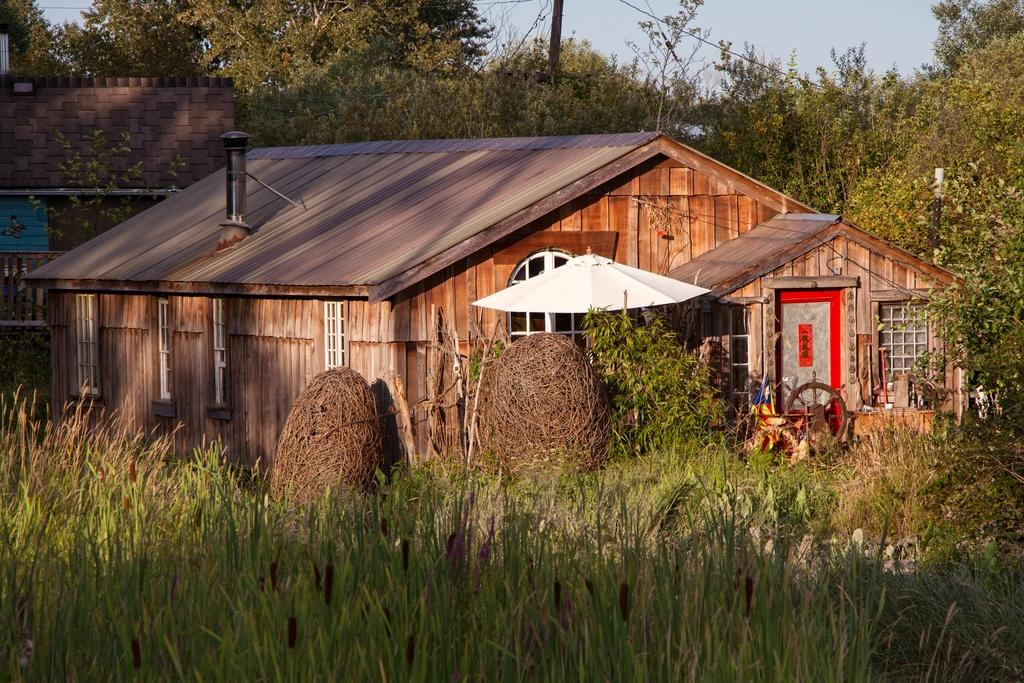What type of house is in the image? There is a wooden house in the image. What can be seen around the house? There are trees and grass around the house. What is in front of the door of the house? There is a wheel in front of the door of the house. Is there a beggar playing a guitar with his brother in the image? There is no beggar, guitar, or brother present in the image. 